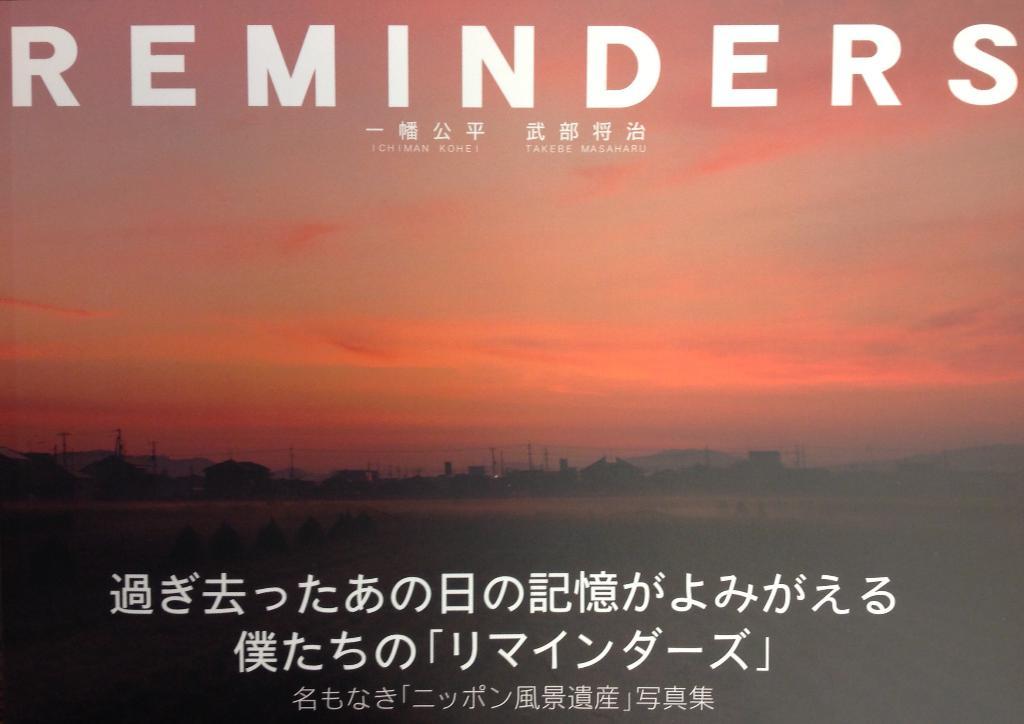What is one of the authors of this book?
Your answer should be very brief. Ichiman kohei. What is the word across the top?
Ensure brevity in your answer.  Reminders. 